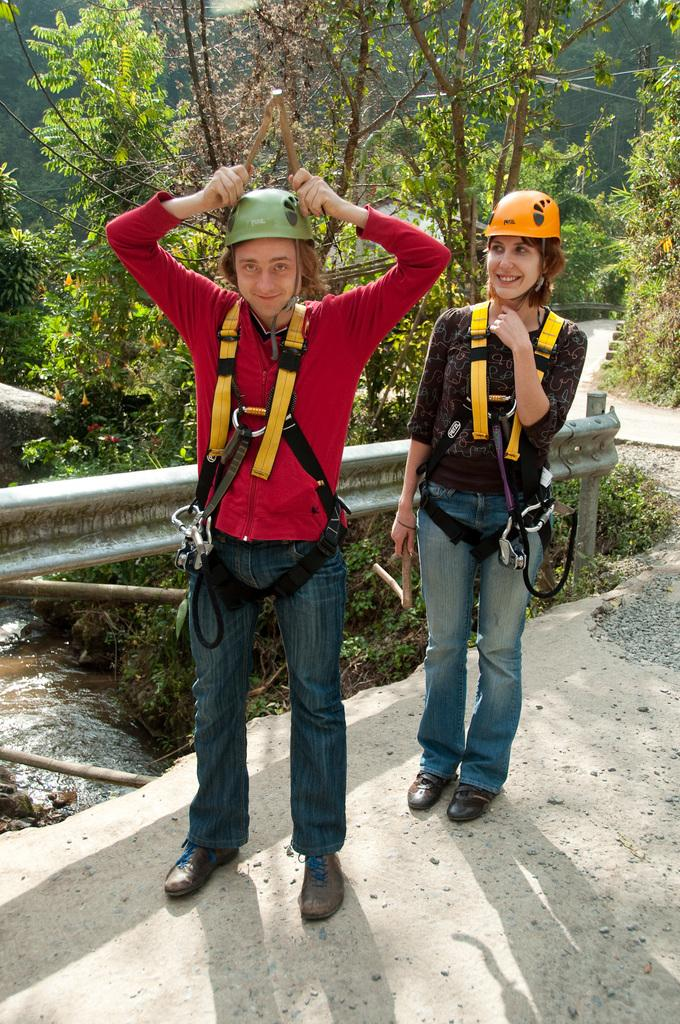How many people are in the image? There are two persons in the image. What are the persons wearing on their heads? The persons are wearing helmets. Where are the persons standing? The persons are standing on the ground. What expression do the persons have? The persons are smiling. What can be seen in the background of the image? Water and trees are visible in the background of the image. What type of engine can be seen in the image? There is no engine present in the image. What kind of shoes are the persons wearing in the image? The image does not show the shoes the persons are wearing. 